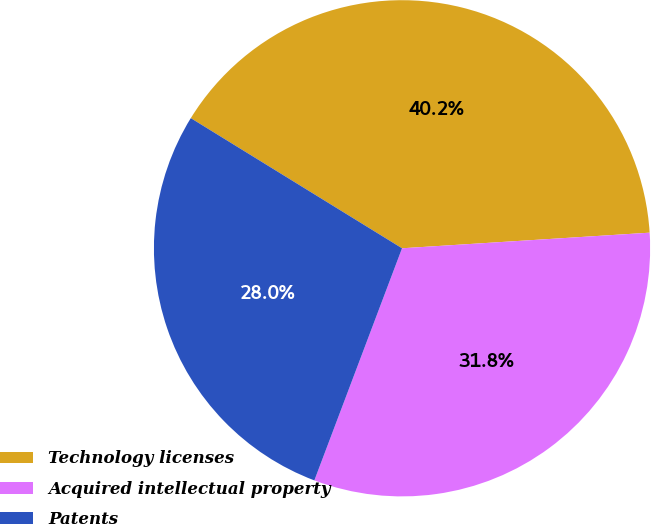Convert chart to OTSL. <chart><loc_0><loc_0><loc_500><loc_500><pie_chart><fcel>Technology licenses<fcel>Acquired intellectual property<fcel>Patents<nl><fcel>40.21%<fcel>31.75%<fcel>28.04%<nl></chart> 